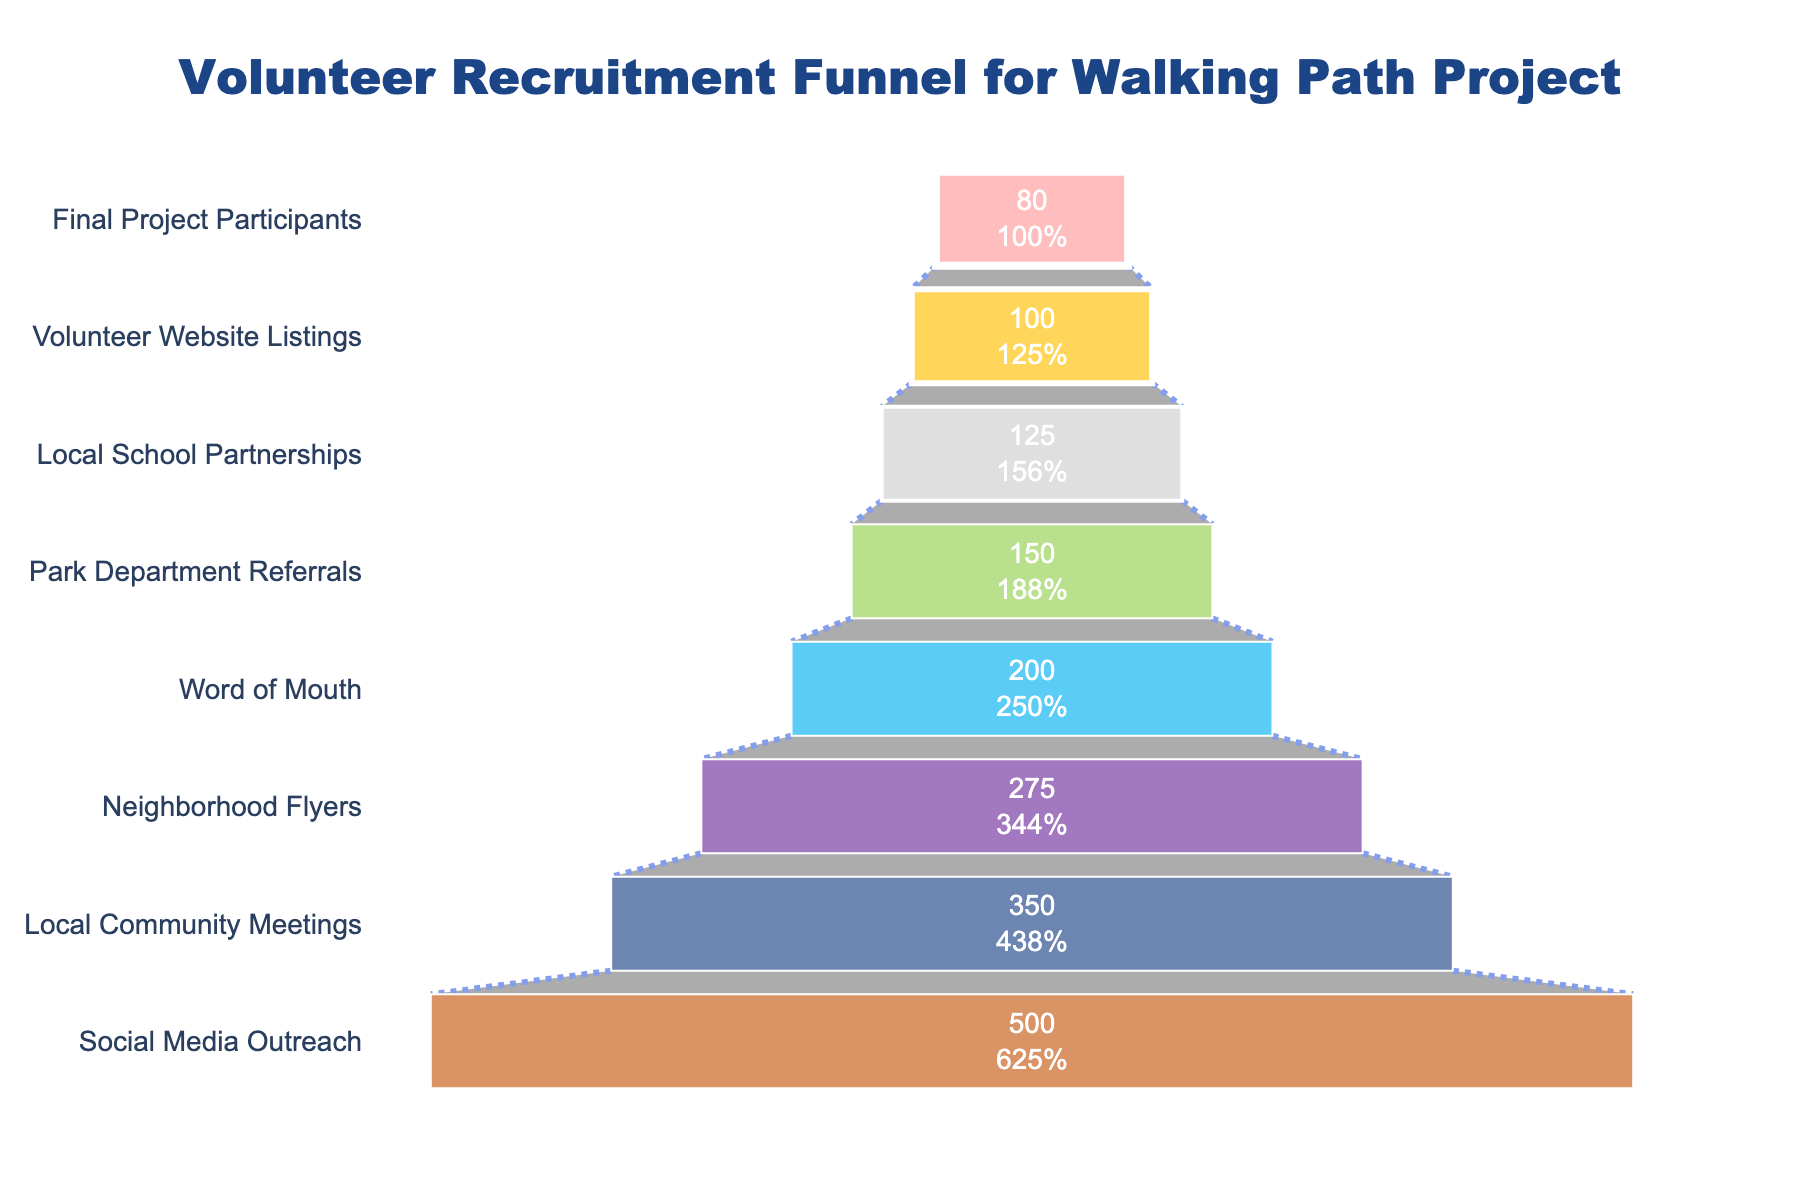What is the title of the chart? The title is located at the top of the figure and is usually written in a larger font size.
Answer: Volunteer Recruitment Funnel for Walking Path Project How many stages are represented in the chart? You can count all the labeled stages listed on the vertical axis of the funnel diagram.
Answer: 8 What is the number of volunteers obtained through Neighborhood Flyers? Locate the "Neighborhood Flyers" stage on the funnel chart and read the value directly inside the stage.
Answer: 275 How many volunteers were finalized as project participants? Find the "Final Project Participants" stage at the bottom of the funnel and determine the number indicated within.
Answer: 80 Which stage has the highest number of volunteers? Identify the stage at the widest part of the funnel (the top), which typically indicates the highest number of volunteers.
Answer: Social Media Outreach How many volunteers were obtained through Word of Mouth and Park Department Referrals combined? Locate the "Word of Mouth" and "Park Department Referrals" stages, note their values (200 and 150 respectively), then sum them up: 200 + 150 = 350
Answer: 350 What is the difference in volunteers between Social Media Outreach and Local Community Meetings? Find the values for "Social Media Outreach" (500) and "Local Community Meetings" (350), then subtract the latter from the former: 500 - 350 = 150
Answer: 150 Which recruitment method contributed fewer volunteers: Local School Partnerships or Volunteer Website Listings? Compare the values of both stages. Local School Partnerships have 125 volunteers and Volunteer Website Listings have 100. 100 is less than 125.
Answer: Volunteer Website Listings By what percentage did the number of volunteers decrease from Social Media Outreach to Final Project Participants? Use the numbers from "Social Media Outreach" (500) and "Final Project Participants" (80). Calculate the percentage decrease using the formula: ((500 - 80) / 500) * 100 ≈ 84%
Answer: 84% What is the cumulative number of volunteers from both Word of Mouth and Neighborhood Flyers stages? Add the number of volunteers from the "Word of Mouth" (200) and "Neighborhood Flyers" (275): 200 + 275 = 475
Answer: 475 